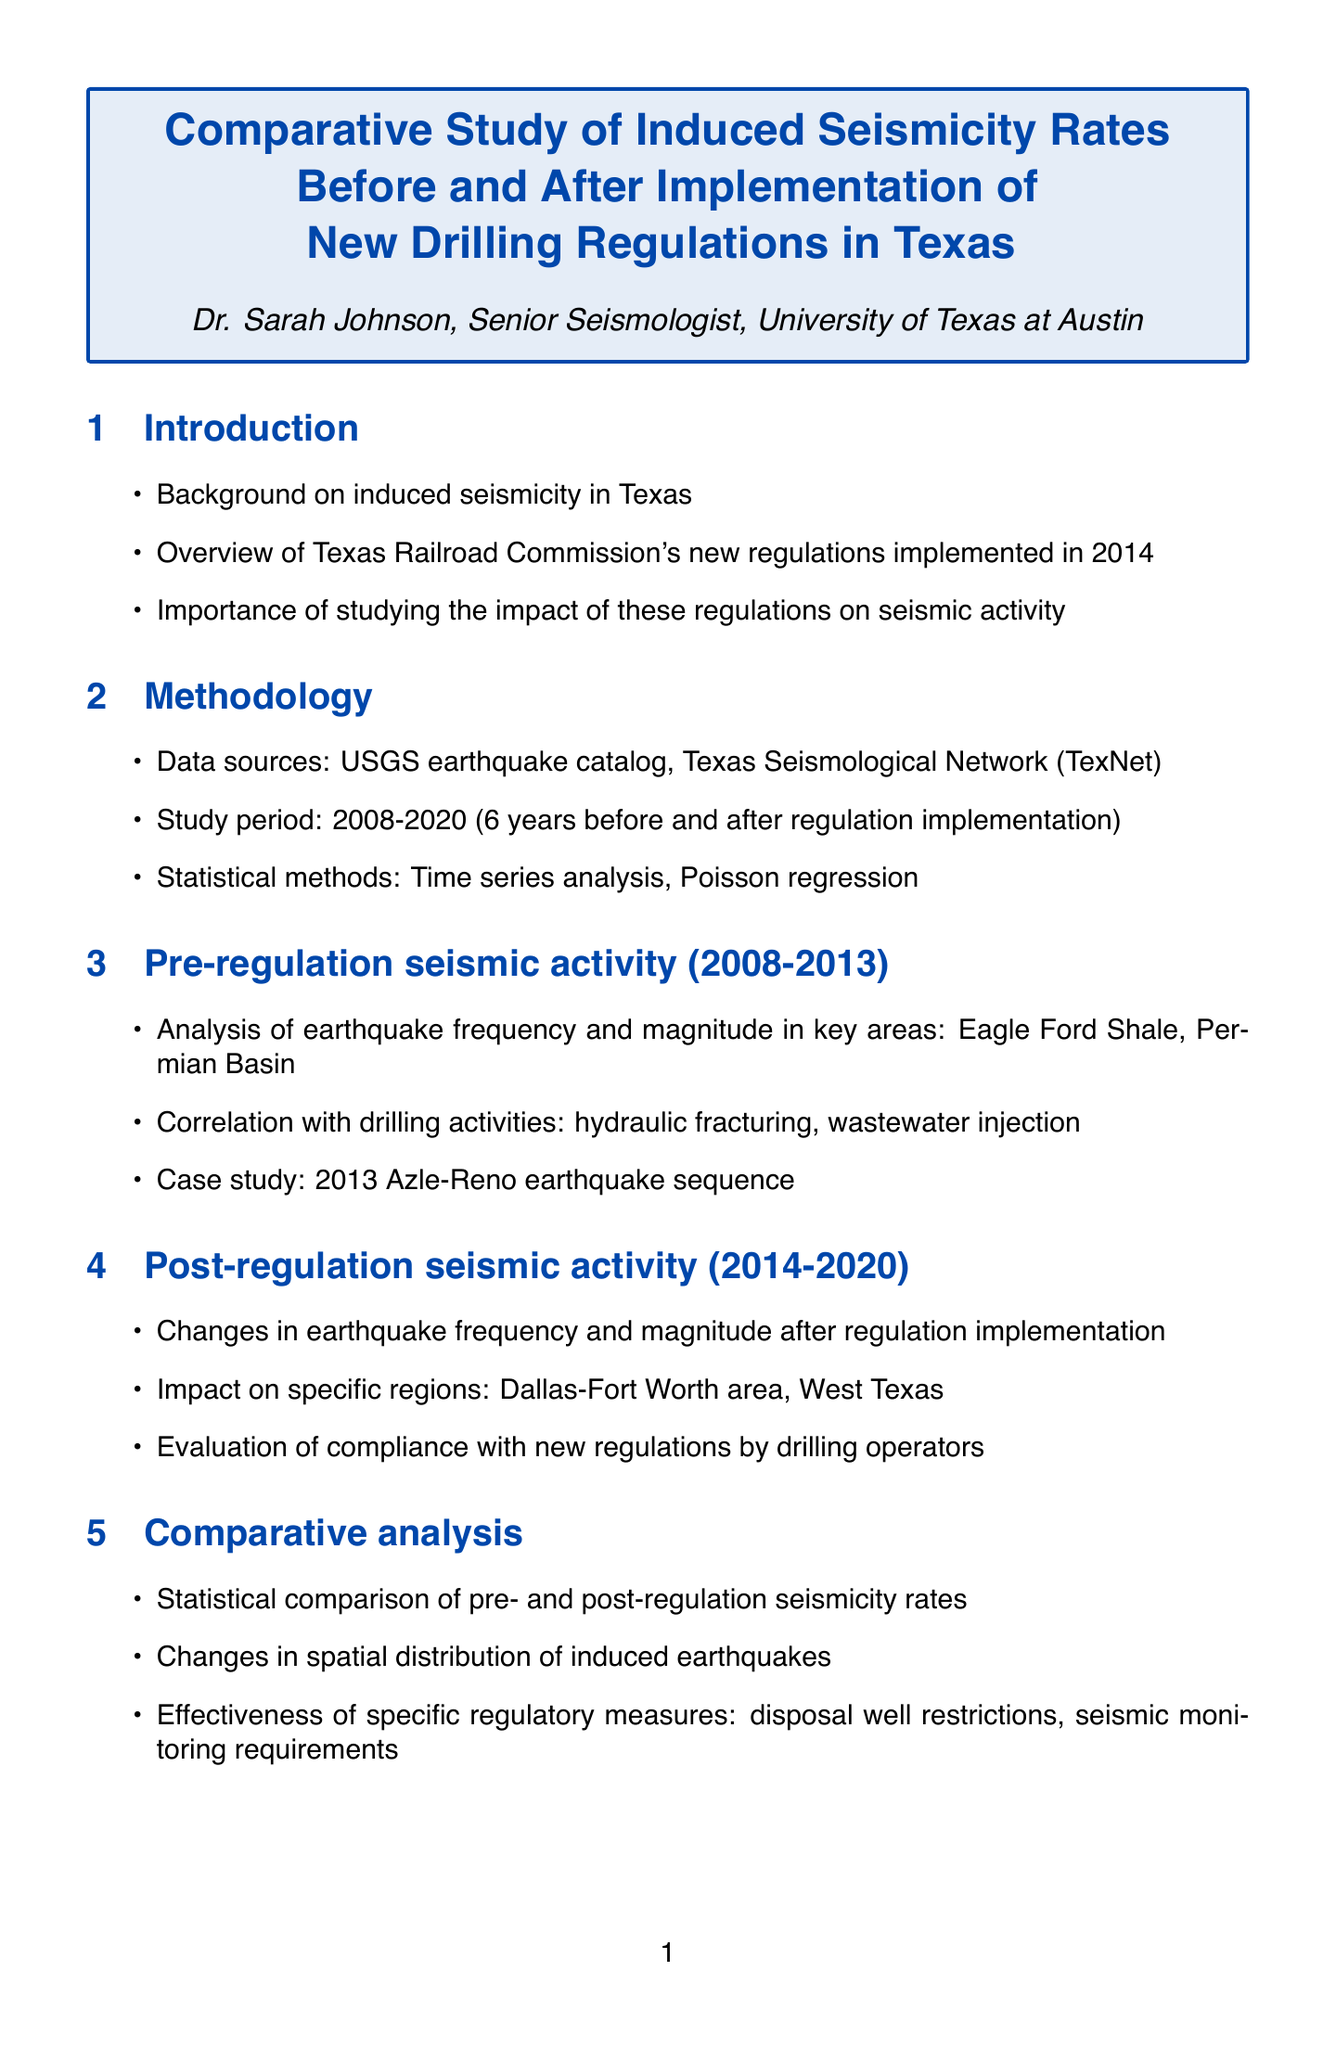What is the title of the report? The title of the report is prominently mentioned at the beginning, which outlines the focus of the study.
Answer: Comparative Study of Induced Seismicity Rates Before and After Implementation of New Drilling Regulations in Texas Who is the author of the report? The author's name is included in the document, indicating their role and affiliation with the research.
Answer: Dr. Sarah Johnson What was the study period for the analysis? The specific period for the study is detailed in the methodology section, indicating the timeframe considered for the data analysis.
Answer: 2008-2020 In which region was the case study conducted? The location of significance discussed in the pre-regulation seismic activity section is specified.
Answer: Azle-Reno What statistical methods were used in the study? The document outlines the statistical methods applied in the methodology section to analyze the data for this study.
Answer: Time series analysis, Poisson regression What new regulations were implemented in Texas? A summary table within the document lists the key regulatory measures that were established in 2014 to address induced seismicity.
Answer: Disposal well restrictions, seismic monitoring requirements How many years of data were analyzed post-regulation? The methodology section indicates the duration of data analyzed after the regulations were implemented.
Answer: 6 years What was the focus area of the post-regulation seismic activity analysis? The specific regions analyzed post-regulation are mentioned in the relevant section discussing changes in seismic activity.
Answer: Dallas-Fort Worth area, West Texas What is a recommendation for future research? The conclusions section provides suggestions aimed at improving ongoing research efforts related to the impact of regulations.
Answer: Suggestions for further improvements in regulatory framework 